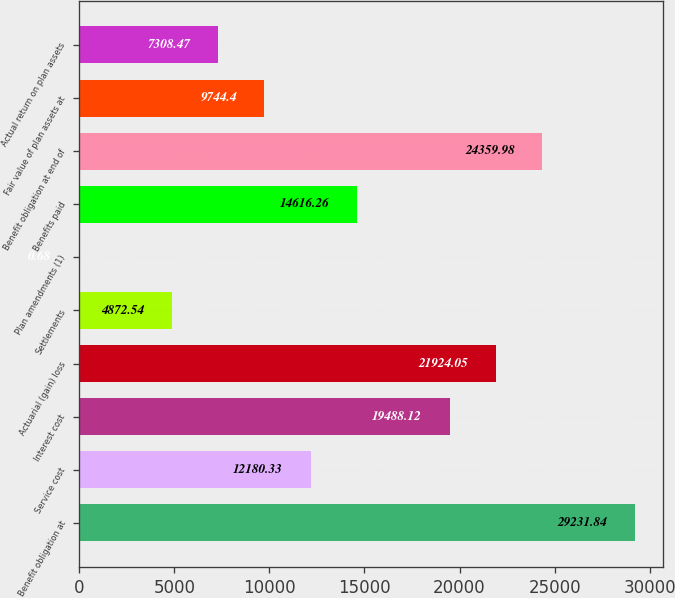Convert chart to OTSL. <chart><loc_0><loc_0><loc_500><loc_500><bar_chart><fcel>Benefit obligation at<fcel>Service cost<fcel>Interest cost<fcel>Actuarial (gain) loss<fcel>Settlements<fcel>Plan amendments (1)<fcel>Benefits paid<fcel>Benefit obligation at end of<fcel>Fair value of plan assets at<fcel>Actual return on plan assets<nl><fcel>29231.8<fcel>12180.3<fcel>19488.1<fcel>21924<fcel>4872.54<fcel>0.68<fcel>14616.3<fcel>24360<fcel>9744.4<fcel>7308.47<nl></chart> 